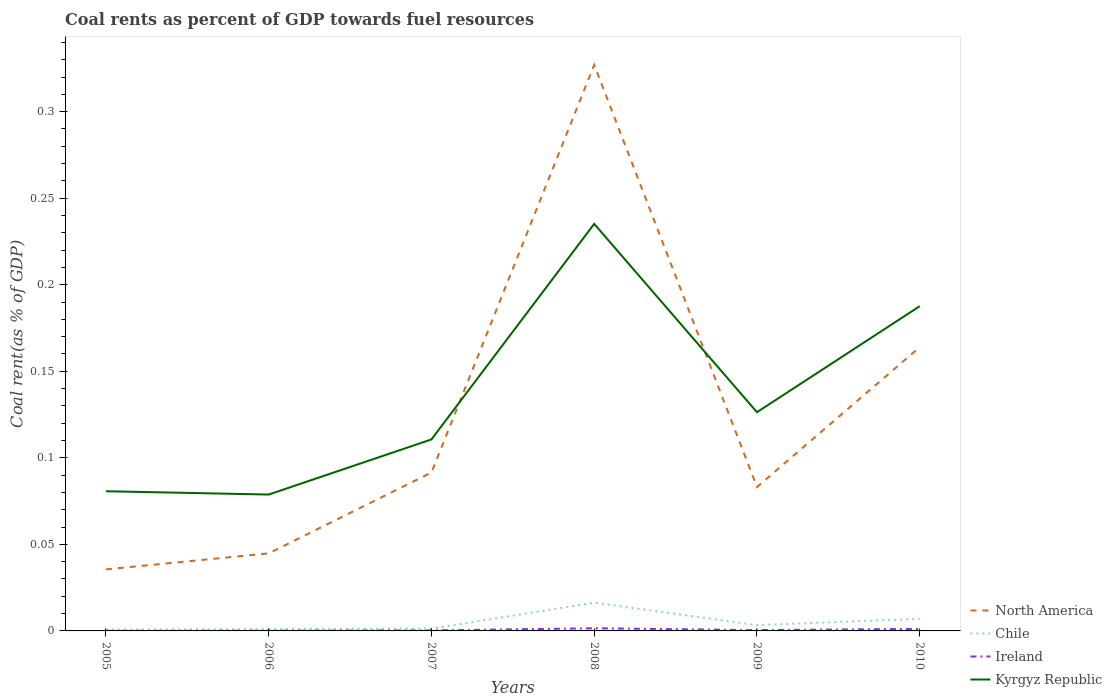How many different coloured lines are there?
Ensure brevity in your answer.  4. Does the line corresponding to Kyrgyz Republic intersect with the line corresponding to Chile?
Give a very brief answer. No. Is the number of lines equal to the number of legend labels?
Your response must be concise. Yes. Across all years, what is the maximum coal rent in Chile?
Offer a very short reply. 0. What is the total coal rent in North America in the graph?
Ensure brevity in your answer.  -0.28. What is the difference between the highest and the second highest coal rent in Ireland?
Offer a very short reply. 0. How many lines are there?
Your answer should be very brief. 4. How many years are there in the graph?
Give a very brief answer. 6. What is the difference between two consecutive major ticks on the Y-axis?
Provide a short and direct response. 0.05. Are the values on the major ticks of Y-axis written in scientific E-notation?
Your answer should be very brief. No. Does the graph contain grids?
Give a very brief answer. No. Where does the legend appear in the graph?
Your answer should be compact. Bottom right. What is the title of the graph?
Your answer should be compact. Coal rents as percent of GDP towards fuel resources. Does "Poland" appear as one of the legend labels in the graph?
Your response must be concise. No. What is the label or title of the X-axis?
Your answer should be very brief. Years. What is the label or title of the Y-axis?
Provide a short and direct response. Coal rent(as % of GDP). What is the Coal rent(as % of GDP) of North America in 2005?
Offer a very short reply. 0.04. What is the Coal rent(as % of GDP) of Chile in 2005?
Keep it short and to the point. 0. What is the Coal rent(as % of GDP) of Ireland in 2005?
Keep it short and to the point. 7.66717495498807e-5. What is the Coal rent(as % of GDP) of Kyrgyz Republic in 2005?
Provide a short and direct response. 0.08. What is the Coal rent(as % of GDP) in North America in 2006?
Keep it short and to the point. 0.04. What is the Coal rent(as % of GDP) of Chile in 2006?
Make the answer very short. 0. What is the Coal rent(as % of GDP) of Ireland in 2006?
Keep it short and to the point. 0. What is the Coal rent(as % of GDP) of Kyrgyz Republic in 2006?
Offer a very short reply. 0.08. What is the Coal rent(as % of GDP) of North America in 2007?
Offer a terse response. 0.09. What is the Coal rent(as % of GDP) of Chile in 2007?
Your answer should be compact. 0. What is the Coal rent(as % of GDP) in Ireland in 2007?
Ensure brevity in your answer.  0. What is the Coal rent(as % of GDP) in Kyrgyz Republic in 2007?
Your answer should be compact. 0.11. What is the Coal rent(as % of GDP) in North America in 2008?
Offer a terse response. 0.33. What is the Coal rent(as % of GDP) in Chile in 2008?
Provide a succinct answer. 0.02. What is the Coal rent(as % of GDP) of Ireland in 2008?
Make the answer very short. 0. What is the Coal rent(as % of GDP) in Kyrgyz Republic in 2008?
Give a very brief answer. 0.24. What is the Coal rent(as % of GDP) in North America in 2009?
Give a very brief answer. 0.08. What is the Coal rent(as % of GDP) of Chile in 2009?
Provide a short and direct response. 0. What is the Coal rent(as % of GDP) in Ireland in 2009?
Give a very brief answer. 0. What is the Coal rent(as % of GDP) of Kyrgyz Republic in 2009?
Provide a short and direct response. 0.13. What is the Coal rent(as % of GDP) of North America in 2010?
Ensure brevity in your answer.  0.16. What is the Coal rent(as % of GDP) of Chile in 2010?
Offer a terse response. 0.01. What is the Coal rent(as % of GDP) of Ireland in 2010?
Your answer should be very brief. 0. What is the Coal rent(as % of GDP) in Kyrgyz Republic in 2010?
Keep it short and to the point. 0.19. Across all years, what is the maximum Coal rent(as % of GDP) in North America?
Offer a terse response. 0.33. Across all years, what is the maximum Coal rent(as % of GDP) of Chile?
Keep it short and to the point. 0.02. Across all years, what is the maximum Coal rent(as % of GDP) of Ireland?
Give a very brief answer. 0. Across all years, what is the maximum Coal rent(as % of GDP) of Kyrgyz Republic?
Provide a succinct answer. 0.24. Across all years, what is the minimum Coal rent(as % of GDP) of North America?
Keep it short and to the point. 0.04. Across all years, what is the minimum Coal rent(as % of GDP) in Chile?
Provide a short and direct response. 0. Across all years, what is the minimum Coal rent(as % of GDP) of Ireland?
Give a very brief answer. 7.66717495498807e-5. Across all years, what is the minimum Coal rent(as % of GDP) in Kyrgyz Republic?
Ensure brevity in your answer.  0.08. What is the total Coal rent(as % of GDP) in North America in the graph?
Your answer should be very brief. 0.75. What is the total Coal rent(as % of GDP) in Chile in the graph?
Offer a terse response. 0.03. What is the total Coal rent(as % of GDP) in Ireland in the graph?
Your answer should be very brief. 0. What is the total Coal rent(as % of GDP) in Kyrgyz Republic in the graph?
Provide a succinct answer. 0.82. What is the difference between the Coal rent(as % of GDP) in North America in 2005 and that in 2006?
Provide a succinct answer. -0.01. What is the difference between the Coal rent(as % of GDP) in Chile in 2005 and that in 2006?
Your response must be concise. -0. What is the difference between the Coal rent(as % of GDP) in Ireland in 2005 and that in 2006?
Provide a succinct answer. -0. What is the difference between the Coal rent(as % of GDP) of Kyrgyz Republic in 2005 and that in 2006?
Your response must be concise. 0. What is the difference between the Coal rent(as % of GDP) of North America in 2005 and that in 2007?
Ensure brevity in your answer.  -0.06. What is the difference between the Coal rent(as % of GDP) in Chile in 2005 and that in 2007?
Keep it short and to the point. -0. What is the difference between the Coal rent(as % of GDP) in Ireland in 2005 and that in 2007?
Offer a terse response. -0. What is the difference between the Coal rent(as % of GDP) of Kyrgyz Republic in 2005 and that in 2007?
Give a very brief answer. -0.03. What is the difference between the Coal rent(as % of GDP) of North America in 2005 and that in 2008?
Your answer should be compact. -0.29. What is the difference between the Coal rent(as % of GDP) of Chile in 2005 and that in 2008?
Offer a terse response. -0.02. What is the difference between the Coal rent(as % of GDP) of Ireland in 2005 and that in 2008?
Provide a short and direct response. -0. What is the difference between the Coal rent(as % of GDP) of Kyrgyz Republic in 2005 and that in 2008?
Offer a terse response. -0.15. What is the difference between the Coal rent(as % of GDP) in North America in 2005 and that in 2009?
Keep it short and to the point. -0.05. What is the difference between the Coal rent(as % of GDP) of Chile in 2005 and that in 2009?
Ensure brevity in your answer.  -0. What is the difference between the Coal rent(as % of GDP) in Ireland in 2005 and that in 2009?
Keep it short and to the point. -0. What is the difference between the Coal rent(as % of GDP) in Kyrgyz Republic in 2005 and that in 2009?
Provide a short and direct response. -0.05. What is the difference between the Coal rent(as % of GDP) in North America in 2005 and that in 2010?
Your answer should be very brief. -0.13. What is the difference between the Coal rent(as % of GDP) in Chile in 2005 and that in 2010?
Your answer should be compact. -0.01. What is the difference between the Coal rent(as % of GDP) in Ireland in 2005 and that in 2010?
Keep it short and to the point. -0. What is the difference between the Coal rent(as % of GDP) in Kyrgyz Republic in 2005 and that in 2010?
Offer a terse response. -0.11. What is the difference between the Coal rent(as % of GDP) of North America in 2006 and that in 2007?
Provide a succinct answer. -0.05. What is the difference between the Coal rent(as % of GDP) in Chile in 2006 and that in 2007?
Ensure brevity in your answer.  -0. What is the difference between the Coal rent(as % of GDP) of Ireland in 2006 and that in 2007?
Ensure brevity in your answer.  -0. What is the difference between the Coal rent(as % of GDP) of Kyrgyz Republic in 2006 and that in 2007?
Give a very brief answer. -0.03. What is the difference between the Coal rent(as % of GDP) in North America in 2006 and that in 2008?
Offer a terse response. -0.28. What is the difference between the Coal rent(as % of GDP) in Chile in 2006 and that in 2008?
Keep it short and to the point. -0.02. What is the difference between the Coal rent(as % of GDP) in Ireland in 2006 and that in 2008?
Ensure brevity in your answer.  -0. What is the difference between the Coal rent(as % of GDP) of Kyrgyz Republic in 2006 and that in 2008?
Your answer should be very brief. -0.16. What is the difference between the Coal rent(as % of GDP) in North America in 2006 and that in 2009?
Offer a terse response. -0.04. What is the difference between the Coal rent(as % of GDP) in Chile in 2006 and that in 2009?
Your response must be concise. -0. What is the difference between the Coal rent(as % of GDP) in Ireland in 2006 and that in 2009?
Your response must be concise. -0. What is the difference between the Coal rent(as % of GDP) in Kyrgyz Republic in 2006 and that in 2009?
Your answer should be very brief. -0.05. What is the difference between the Coal rent(as % of GDP) of North America in 2006 and that in 2010?
Provide a succinct answer. -0.12. What is the difference between the Coal rent(as % of GDP) of Chile in 2006 and that in 2010?
Offer a very short reply. -0.01. What is the difference between the Coal rent(as % of GDP) of Ireland in 2006 and that in 2010?
Give a very brief answer. -0. What is the difference between the Coal rent(as % of GDP) in Kyrgyz Republic in 2006 and that in 2010?
Keep it short and to the point. -0.11. What is the difference between the Coal rent(as % of GDP) in North America in 2007 and that in 2008?
Offer a very short reply. -0.24. What is the difference between the Coal rent(as % of GDP) in Chile in 2007 and that in 2008?
Ensure brevity in your answer.  -0.01. What is the difference between the Coal rent(as % of GDP) of Ireland in 2007 and that in 2008?
Give a very brief answer. -0. What is the difference between the Coal rent(as % of GDP) of Kyrgyz Republic in 2007 and that in 2008?
Offer a very short reply. -0.12. What is the difference between the Coal rent(as % of GDP) of North America in 2007 and that in 2009?
Offer a terse response. 0.01. What is the difference between the Coal rent(as % of GDP) in Chile in 2007 and that in 2009?
Make the answer very short. -0. What is the difference between the Coal rent(as % of GDP) in Ireland in 2007 and that in 2009?
Provide a short and direct response. -0. What is the difference between the Coal rent(as % of GDP) of Kyrgyz Republic in 2007 and that in 2009?
Your answer should be very brief. -0.02. What is the difference between the Coal rent(as % of GDP) in North America in 2007 and that in 2010?
Give a very brief answer. -0.07. What is the difference between the Coal rent(as % of GDP) in Chile in 2007 and that in 2010?
Your answer should be compact. -0.01. What is the difference between the Coal rent(as % of GDP) in Ireland in 2007 and that in 2010?
Provide a succinct answer. -0. What is the difference between the Coal rent(as % of GDP) of Kyrgyz Republic in 2007 and that in 2010?
Offer a very short reply. -0.08. What is the difference between the Coal rent(as % of GDP) in North America in 2008 and that in 2009?
Provide a succinct answer. 0.24. What is the difference between the Coal rent(as % of GDP) of Chile in 2008 and that in 2009?
Offer a very short reply. 0.01. What is the difference between the Coal rent(as % of GDP) in Kyrgyz Republic in 2008 and that in 2009?
Provide a succinct answer. 0.11. What is the difference between the Coal rent(as % of GDP) in North America in 2008 and that in 2010?
Provide a short and direct response. 0.16. What is the difference between the Coal rent(as % of GDP) in Chile in 2008 and that in 2010?
Offer a very short reply. 0.01. What is the difference between the Coal rent(as % of GDP) in Ireland in 2008 and that in 2010?
Ensure brevity in your answer.  0. What is the difference between the Coal rent(as % of GDP) of Kyrgyz Republic in 2008 and that in 2010?
Ensure brevity in your answer.  0.05. What is the difference between the Coal rent(as % of GDP) in North America in 2009 and that in 2010?
Provide a succinct answer. -0.08. What is the difference between the Coal rent(as % of GDP) of Chile in 2009 and that in 2010?
Offer a terse response. -0. What is the difference between the Coal rent(as % of GDP) of Ireland in 2009 and that in 2010?
Offer a terse response. -0. What is the difference between the Coal rent(as % of GDP) of Kyrgyz Republic in 2009 and that in 2010?
Offer a very short reply. -0.06. What is the difference between the Coal rent(as % of GDP) of North America in 2005 and the Coal rent(as % of GDP) of Chile in 2006?
Give a very brief answer. 0.03. What is the difference between the Coal rent(as % of GDP) of North America in 2005 and the Coal rent(as % of GDP) of Ireland in 2006?
Make the answer very short. 0.04. What is the difference between the Coal rent(as % of GDP) in North America in 2005 and the Coal rent(as % of GDP) in Kyrgyz Republic in 2006?
Keep it short and to the point. -0.04. What is the difference between the Coal rent(as % of GDP) in Chile in 2005 and the Coal rent(as % of GDP) in Ireland in 2006?
Provide a short and direct response. 0. What is the difference between the Coal rent(as % of GDP) of Chile in 2005 and the Coal rent(as % of GDP) of Kyrgyz Republic in 2006?
Give a very brief answer. -0.08. What is the difference between the Coal rent(as % of GDP) of Ireland in 2005 and the Coal rent(as % of GDP) of Kyrgyz Republic in 2006?
Your answer should be very brief. -0.08. What is the difference between the Coal rent(as % of GDP) in North America in 2005 and the Coal rent(as % of GDP) in Chile in 2007?
Your response must be concise. 0.03. What is the difference between the Coal rent(as % of GDP) in North America in 2005 and the Coal rent(as % of GDP) in Ireland in 2007?
Make the answer very short. 0.04. What is the difference between the Coal rent(as % of GDP) of North America in 2005 and the Coal rent(as % of GDP) of Kyrgyz Republic in 2007?
Your response must be concise. -0.08. What is the difference between the Coal rent(as % of GDP) of Chile in 2005 and the Coal rent(as % of GDP) of Ireland in 2007?
Ensure brevity in your answer.  0. What is the difference between the Coal rent(as % of GDP) of Chile in 2005 and the Coal rent(as % of GDP) of Kyrgyz Republic in 2007?
Ensure brevity in your answer.  -0.11. What is the difference between the Coal rent(as % of GDP) of Ireland in 2005 and the Coal rent(as % of GDP) of Kyrgyz Republic in 2007?
Your answer should be very brief. -0.11. What is the difference between the Coal rent(as % of GDP) of North America in 2005 and the Coal rent(as % of GDP) of Chile in 2008?
Offer a terse response. 0.02. What is the difference between the Coal rent(as % of GDP) in North America in 2005 and the Coal rent(as % of GDP) in Ireland in 2008?
Keep it short and to the point. 0.03. What is the difference between the Coal rent(as % of GDP) in North America in 2005 and the Coal rent(as % of GDP) in Kyrgyz Republic in 2008?
Your response must be concise. -0.2. What is the difference between the Coal rent(as % of GDP) of Chile in 2005 and the Coal rent(as % of GDP) of Ireland in 2008?
Your answer should be compact. -0. What is the difference between the Coal rent(as % of GDP) of Chile in 2005 and the Coal rent(as % of GDP) of Kyrgyz Republic in 2008?
Offer a very short reply. -0.23. What is the difference between the Coal rent(as % of GDP) of Ireland in 2005 and the Coal rent(as % of GDP) of Kyrgyz Republic in 2008?
Your response must be concise. -0.24. What is the difference between the Coal rent(as % of GDP) in North America in 2005 and the Coal rent(as % of GDP) in Chile in 2009?
Your answer should be very brief. 0.03. What is the difference between the Coal rent(as % of GDP) of North America in 2005 and the Coal rent(as % of GDP) of Ireland in 2009?
Offer a very short reply. 0.04. What is the difference between the Coal rent(as % of GDP) in North America in 2005 and the Coal rent(as % of GDP) in Kyrgyz Republic in 2009?
Give a very brief answer. -0.09. What is the difference between the Coal rent(as % of GDP) of Chile in 2005 and the Coal rent(as % of GDP) of Kyrgyz Republic in 2009?
Offer a terse response. -0.13. What is the difference between the Coal rent(as % of GDP) of Ireland in 2005 and the Coal rent(as % of GDP) of Kyrgyz Republic in 2009?
Offer a terse response. -0.13. What is the difference between the Coal rent(as % of GDP) of North America in 2005 and the Coal rent(as % of GDP) of Chile in 2010?
Your answer should be very brief. 0.03. What is the difference between the Coal rent(as % of GDP) in North America in 2005 and the Coal rent(as % of GDP) in Ireland in 2010?
Ensure brevity in your answer.  0.03. What is the difference between the Coal rent(as % of GDP) in North America in 2005 and the Coal rent(as % of GDP) in Kyrgyz Republic in 2010?
Your response must be concise. -0.15. What is the difference between the Coal rent(as % of GDP) in Chile in 2005 and the Coal rent(as % of GDP) in Ireland in 2010?
Offer a very short reply. -0. What is the difference between the Coal rent(as % of GDP) of Chile in 2005 and the Coal rent(as % of GDP) of Kyrgyz Republic in 2010?
Make the answer very short. -0.19. What is the difference between the Coal rent(as % of GDP) of Ireland in 2005 and the Coal rent(as % of GDP) of Kyrgyz Republic in 2010?
Offer a terse response. -0.19. What is the difference between the Coal rent(as % of GDP) in North America in 2006 and the Coal rent(as % of GDP) in Chile in 2007?
Provide a short and direct response. 0.04. What is the difference between the Coal rent(as % of GDP) of North America in 2006 and the Coal rent(as % of GDP) of Ireland in 2007?
Your response must be concise. 0.04. What is the difference between the Coal rent(as % of GDP) of North America in 2006 and the Coal rent(as % of GDP) of Kyrgyz Republic in 2007?
Provide a short and direct response. -0.07. What is the difference between the Coal rent(as % of GDP) of Chile in 2006 and the Coal rent(as % of GDP) of Ireland in 2007?
Provide a short and direct response. 0. What is the difference between the Coal rent(as % of GDP) in Chile in 2006 and the Coal rent(as % of GDP) in Kyrgyz Republic in 2007?
Your answer should be very brief. -0.11. What is the difference between the Coal rent(as % of GDP) of Ireland in 2006 and the Coal rent(as % of GDP) of Kyrgyz Republic in 2007?
Your response must be concise. -0.11. What is the difference between the Coal rent(as % of GDP) of North America in 2006 and the Coal rent(as % of GDP) of Chile in 2008?
Provide a succinct answer. 0.03. What is the difference between the Coal rent(as % of GDP) in North America in 2006 and the Coal rent(as % of GDP) in Ireland in 2008?
Ensure brevity in your answer.  0.04. What is the difference between the Coal rent(as % of GDP) of North America in 2006 and the Coal rent(as % of GDP) of Kyrgyz Republic in 2008?
Ensure brevity in your answer.  -0.19. What is the difference between the Coal rent(as % of GDP) of Chile in 2006 and the Coal rent(as % of GDP) of Ireland in 2008?
Make the answer very short. -0. What is the difference between the Coal rent(as % of GDP) of Chile in 2006 and the Coal rent(as % of GDP) of Kyrgyz Republic in 2008?
Offer a very short reply. -0.23. What is the difference between the Coal rent(as % of GDP) of Ireland in 2006 and the Coal rent(as % of GDP) of Kyrgyz Republic in 2008?
Give a very brief answer. -0.24. What is the difference between the Coal rent(as % of GDP) of North America in 2006 and the Coal rent(as % of GDP) of Chile in 2009?
Your answer should be compact. 0.04. What is the difference between the Coal rent(as % of GDP) in North America in 2006 and the Coal rent(as % of GDP) in Ireland in 2009?
Offer a terse response. 0.04. What is the difference between the Coal rent(as % of GDP) of North America in 2006 and the Coal rent(as % of GDP) of Kyrgyz Republic in 2009?
Make the answer very short. -0.08. What is the difference between the Coal rent(as % of GDP) of Chile in 2006 and the Coal rent(as % of GDP) of Ireland in 2009?
Keep it short and to the point. 0. What is the difference between the Coal rent(as % of GDP) in Chile in 2006 and the Coal rent(as % of GDP) in Kyrgyz Republic in 2009?
Your answer should be compact. -0.13. What is the difference between the Coal rent(as % of GDP) in Ireland in 2006 and the Coal rent(as % of GDP) in Kyrgyz Republic in 2009?
Offer a very short reply. -0.13. What is the difference between the Coal rent(as % of GDP) in North America in 2006 and the Coal rent(as % of GDP) in Chile in 2010?
Keep it short and to the point. 0.04. What is the difference between the Coal rent(as % of GDP) of North America in 2006 and the Coal rent(as % of GDP) of Ireland in 2010?
Offer a terse response. 0.04. What is the difference between the Coal rent(as % of GDP) of North America in 2006 and the Coal rent(as % of GDP) of Kyrgyz Republic in 2010?
Provide a short and direct response. -0.14. What is the difference between the Coal rent(as % of GDP) of Chile in 2006 and the Coal rent(as % of GDP) of Ireland in 2010?
Offer a terse response. -0. What is the difference between the Coal rent(as % of GDP) of Chile in 2006 and the Coal rent(as % of GDP) of Kyrgyz Republic in 2010?
Ensure brevity in your answer.  -0.19. What is the difference between the Coal rent(as % of GDP) of Ireland in 2006 and the Coal rent(as % of GDP) of Kyrgyz Republic in 2010?
Your answer should be very brief. -0.19. What is the difference between the Coal rent(as % of GDP) of North America in 2007 and the Coal rent(as % of GDP) of Chile in 2008?
Offer a very short reply. 0.08. What is the difference between the Coal rent(as % of GDP) in North America in 2007 and the Coal rent(as % of GDP) in Ireland in 2008?
Your response must be concise. 0.09. What is the difference between the Coal rent(as % of GDP) of North America in 2007 and the Coal rent(as % of GDP) of Kyrgyz Republic in 2008?
Your answer should be compact. -0.14. What is the difference between the Coal rent(as % of GDP) of Chile in 2007 and the Coal rent(as % of GDP) of Ireland in 2008?
Offer a terse response. -0. What is the difference between the Coal rent(as % of GDP) in Chile in 2007 and the Coal rent(as % of GDP) in Kyrgyz Republic in 2008?
Provide a succinct answer. -0.23. What is the difference between the Coal rent(as % of GDP) in Ireland in 2007 and the Coal rent(as % of GDP) in Kyrgyz Republic in 2008?
Your answer should be very brief. -0.23. What is the difference between the Coal rent(as % of GDP) of North America in 2007 and the Coal rent(as % of GDP) of Chile in 2009?
Your answer should be very brief. 0.09. What is the difference between the Coal rent(as % of GDP) in North America in 2007 and the Coal rent(as % of GDP) in Ireland in 2009?
Provide a short and direct response. 0.09. What is the difference between the Coal rent(as % of GDP) of North America in 2007 and the Coal rent(as % of GDP) of Kyrgyz Republic in 2009?
Your answer should be very brief. -0.03. What is the difference between the Coal rent(as % of GDP) of Chile in 2007 and the Coal rent(as % of GDP) of Ireland in 2009?
Your answer should be compact. 0. What is the difference between the Coal rent(as % of GDP) of Chile in 2007 and the Coal rent(as % of GDP) of Kyrgyz Republic in 2009?
Offer a very short reply. -0.12. What is the difference between the Coal rent(as % of GDP) in Ireland in 2007 and the Coal rent(as % of GDP) in Kyrgyz Republic in 2009?
Keep it short and to the point. -0.13. What is the difference between the Coal rent(as % of GDP) in North America in 2007 and the Coal rent(as % of GDP) in Chile in 2010?
Provide a short and direct response. 0.08. What is the difference between the Coal rent(as % of GDP) of North America in 2007 and the Coal rent(as % of GDP) of Ireland in 2010?
Make the answer very short. 0.09. What is the difference between the Coal rent(as % of GDP) in North America in 2007 and the Coal rent(as % of GDP) in Kyrgyz Republic in 2010?
Give a very brief answer. -0.1. What is the difference between the Coal rent(as % of GDP) of Chile in 2007 and the Coal rent(as % of GDP) of Ireland in 2010?
Provide a short and direct response. 0. What is the difference between the Coal rent(as % of GDP) in Chile in 2007 and the Coal rent(as % of GDP) in Kyrgyz Republic in 2010?
Your response must be concise. -0.19. What is the difference between the Coal rent(as % of GDP) in Ireland in 2007 and the Coal rent(as % of GDP) in Kyrgyz Republic in 2010?
Give a very brief answer. -0.19. What is the difference between the Coal rent(as % of GDP) in North America in 2008 and the Coal rent(as % of GDP) in Chile in 2009?
Your answer should be very brief. 0.32. What is the difference between the Coal rent(as % of GDP) in North America in 2008 and the Coal rent(as % of GDP) in Ireland in 2009?
Offer a very short reply. 0.33. What is the difference between the Coal rent(as % of GDP) in North America in 2008 and the Coal rent(as % of GDP) in Kyrgyz Republic in 2009?
Provide a short and direct response. 0.2. What is the difference between the Coal rent(as % of GDP) of Chile in 2008 and the Coal rent(as % of GDP) of Ireland in 2009?
Provide a succinct answer. 0.02. What is the difference between the Coal rent(as % of GDP) in Chile in 2008 and the Coal rent(as % of GDP) in Kyrgyz Republic in 2009?
Offer a terse response. -0.11. What is the difference between the Coal rent(as % of GDP) of Ireland in 2008 and the Coal rent(as % of GDP) of Kyrgyz Republic in 2009?
Provide a short and direct response. -0.12. What is the difference between the Coal rent(as % of GDP) in North America in 2008 and the Coal rent(as % of GDP) in Chile in 2010?
Give a very brief answer. 0.32. What is the difference between the Coal rent(as % of GDP) in North America in 2008 and the Coal rent(as % of GDP) in Ireland in 2010?
Your response must be concise. 0.33. What is the difference between the Coal rent(as % of GDP) in North America in 2008 and the Coal rent(as % of GDP) in Kyrgyz Republic in 2010?
Offer a very short reply. 0.14. What is the difference between the Coal rent(as % of GDP) of Chile in 2008 and the Coal rent(as % of GDP) of Ireland in 2010?
Your response must be concise. 0.02. What is the difference between the Coal rent(as % of GDP) in Chile in 2008 and the Coal rent(as % of GDP) in Kyrgyz Republic in 2010?
Offer a terse response. -0.17. What is the difference between the Coal rent(as % of GDP) of Ireland in 2008 and the Coal rent(as % of GDP) of Kyrgyz Republic in 2010?
Keep it short and to the point. -0.19. What is the difference between the Coal rent(as % of GDP) in North America in 2009 and the Coal rent(as % of GDP) in Chile in 2010?
Give a very brief answer. 0.08. What is the difference between the Coal rent(as % of GDP) of North America in 2009 and the Coal rent(as % of GDP) of Ireland in 2010?
Offer a very short reply. 0.08. What is the difference between the Coal rent(as % of GDP) in North America in 2009 and the Coal rent(as % of GDP) in Kyrgyz Republic in 2010?
Give a very brief answer. -0.1. What is the difference between the Coal rent(as % of GDP) in Chile in 2009 and the Coal rent(as % of GDP) in Ireland in 2010?
Keep it short and to the point. 0. What is the difference between the Coal rent(as % of GDP) in Chile in 2009 and the Coal rent(as % of GDP) in Kyrgyz Republic in 2010?
Keep it short and to the point. -0.18. What is the difference between the Coal rent(as % of GDP) in Ireland in 2009 and the Coal rent(as % of GDP) in Kyrgyz Republic in 2010?
Ensure brevity in your answer.  -0.19. What is the average Coal rent(as % of GDP) of North America per year?
Provide a succinct answer. 0.12. What is the average Coal rent(as % of GDP) in Chile per year?
Your answer should be compact. 0.01. What is the average Coal rent(as % of GDP) in Ireland per year?
Offer a terse response. 0. What is the average Coal rent(as % of GDP) in Kyrgyz Republic per year?
Your response must be concise. 0.14. In the year 2005, what is the difference between the Coal rent(as % of GDP) in North America and Coal rent(as % of GDP) in Chile?
Your answer should be compact. 0.03. In the year 2005, what is the difference between the Coal rent(as % of GDP) of North America and Coal rent(as % of GDP) of Ireland?
Provide a short and direct response. 0.04. In the year 2005, what is the difference between the Coal rent(as % of GDP) of North America and Coal rent(as % of GDP) of Kyrgyz Republic?
Your answer should be very brief. -0.05. In the year 2005, what is the difference between the Coal rent(as % of GDP) of Chile and Coal rent(as % of GDP) of Ireland?
Ensure brevity in your answer.  0. In the year 2005, what is the difference between the Coal rent(as % of GDP) in Chile and Coal rent(as % of GDP) in Kyrgyz Republic?
Your answer should be compact. -0.08. In the year 2005, what is the difference between the Coal rent(as % of GDP) of Ireland and Coal rent(as % of GDP) of Kyrgyz Republic?
Your answer should be compact. -0.08. In the year 2006, what is the difference between the Coal rent(as % of GDP) in North America and Coal rent(as % of GDP) in Chile?
Make the answer very short. 0.04. In the year 2006, what is the difference between the Coal rent(as % of GDP) in North America and Coal rent(as % of GDP) in Ireland?
Give a very brief answer. 0.04. In the year 2006, what is the difference between the Coal rent(as % of GDP) in North America and Coal rent(as % of GDP) in Kyrgyz Republic?
Make the answer very short. -0.03. In the year 2006, what is the difference between the Coal rent(as % of GDP) of Chile and Coal rent(as % of GDP) of Ireland?
Your answer should be very brief. 0. In the year 2006, what is the difference between the Coal rent(as % of GDP) in Chile and Coal rent(as % of GDP) in Kyrgyz Republic?
Make the answer very short. -0.08. In the year 2006, what is the difference between the Coal rent(as % of GDP) of Ireland and Coal rent(as % of GDP) of Kyrgyz Republic?
Offer a terse response. -0.08. In the year 2007, what is the difference between the Coal rent(as % of GDP) of North America and Coal rent(as % of GDP) of Chile?
Keep it short and to the point. 0.09. In the year 2007, what is the difference between the Coal rent(as % of GDP) in North America and Coal rent(as % of GDP) in Ireland?
Ensure brevity in your answer.  0.09. In the year 2007, what is the difference between the Coal rent(as % of GDP) in North America and Coal rent(as % of GDP) in Kyrgyz Republic?
Make the answer very short. -0.02. In the year 2007, what is the difference between the Coal rent(as % of GDP) in Chile and Coal rent(as % of GDP) in Ireland?
Your response must be concise. 0. In the year 2007, what is the difference between the Coal rent(as % of GDP) of Chile and Coal rent(as % of GDP) of Kyrgyz Republic?
Make the answer very short. -0.11. In the year 2007, what is the difference between the Coal rent(as % of GDP) of Ireland and Coal rent(as % of GDP) of Kyrgyz Republic?
Offer a very short reply. -0.11. In the year 2008, what is the difference between the Coal rent(as % of GDP) in North America and Coal rent(as % of GDP) in Chile?
Your answer should be compact. 0.31. In the year 2008, what is the difference between the Coal rent(as % of GDP) of North America and Coal rent(as % of GDP) of Ireland?
Keep it short and to the point. 0.33. In the year 2008, what is the difference between the Coal rent(as % of GDP) in North America and Coal rent(as % of GDP) in Kyrgyz Republic?
Make the answer very short. 0.09. In the year 2008, what is the difference between the Coal rent(as % of GDP) in Chile and Coal rent(as % of GDP) in Ireland?
Give a very brief answer. 0.01. In the year 2008, what is the difference between the Coal rent(as % of GDP) in Chile and Coal rent(as % of GDP) in Kyrgyz Republic?
Your response must be concise. -0.22. In the year 2008, what is the difference between the Coal rent(as % of GDP) in Ireland and Coal rent(as % of GDP) in Kyrgyz Republic?
Provide a short and direct response. -0.23. In the year 2009, what is the difference between the Coal rent(as % of GDP) in North America and Coal rent(as % of GDP) in Chile?
Your answer should be compact. 0.08. In the year 2009, what is the difference between the Coal rent(as % of GDP) of North America and Coal rent(as % of GDP) of Ireland?
Ensure brevity in your answer.  0.08. In the year 2009, what is the difference between the Coal rent(as % of GDP) in North America and Coal rent(as % of GDP) in Kyrgyz Republic?
Keep it short and to the point. -0.04. In the year 2009, what is the difference between the Coal rent(as % of GDP) of Chile and Coal rent(as % of GDP) of Ireland?
Offer a terse response. 0. In the year 2009, what is the difference between the Coal rent(as % of GDP) of Chile and Coal rent(as % of GDP) of Kyrgyz Republic?
Offer a terse response. -0.12. In the year 2009, what is the difference between the Coal rent(as % of GDP) of Ireland and Coal rent(as % of GDP) of Kyrgyz Republic?
Provide a short and direct response. -0.13. In the year 2010, what is the difference between the Coal rent(as % of GDP) of North America and Coal rent(as % of GDP) of Chile?
Make the answer very short. 0.16. In the year 2010, what is the difference between the Coal rent(as % of GDP) of North America and Coal rent(as % of GDP) of Ireland?
Give a very brief answer. 0.16. In the year 2010, what is the difference between the Coal rent(as % of GDP) of North America and Coal rent(as % of GDP) of Kyrgyz Republic?
Offer a very short reply. -0.02. In the year 2010, what is the difference between the Coal rent(as % of GDP) in Chile and Coal rent(as % of GDP) in Ireland?
Offer a terse response. 0.01. In the year 2010, what is the difference between the Coal rent(as % of GDP) in Chile and Coal rent(as % of GDP) in Kyrgyz Republic?
Offer a very short reply. -0.18. In the year 2010, what is the difference between the Coal rent(as % of GDP) of Ireland and Coal rent(as % of GDP) of Kyrgyz Republic?
Make the answer very short. -0.19. What is the ratio of the Coal rent(as % of GDP) of North America in 2005 to that in 2006?
Ensure brevity in your answer.  0.79. What is the ratio of the Coal rent(as % of GDP) of Chile in 2005 to that in 2006?
Your response must be concise. 0.69. What is the ratio of the Coal rent(as % of GDP) in Ireland in 2005 to that in 2006?
Give a very brief answer. 0.67. What is the ratio of the Coal rent(as % of GDP) in Kyrgyz Republic in 2005 to that in 2006?
Offer a very short reply. 1.02. What is the ratio of the Coal rent(as % of GDP) of North America in 2005 to that in 2007?
Ensure brevity in your answer.  0.39. What is the ratio of the Coal rent(as % of GDP) of Chile in 2005 to that in 2007?
Provide a short and direct response. 0.53. What is the ratio of the Coal rent(as % of GDP) in Ireland in 2005 to that in 2007?
Offer a very short reply. 0.25. What is the ratio of the Coal rent(as % of GDP) of Kyrgyz Republic in 2005 to that in 2007?
Your answer should be compact. 0.73. What is the ratio of the Coal rent(as % of GDP) of North America in 2005 to that in 2008?
Your answer should be compact. 0.11. What is the ratio of the Coal rent(as % of GDP) of Chile in 2005 to that in 2008?
Keep it short and to the point. 0.04. What is the ratio of the Coal rent(as % of GDP) of Ireland in 2005 to that in 2008?
Your answer should be very brief. 0.05. What is the ratio of the Coal rent(as % of GDP) in Kyrgyz Republic in 2005 to that in 2008?
Your response must be concise. 0.34. What is the ratio of the Coal rent(as % of GDP) of North America in 2005 to that in 2009?
Give a very brief answer. 0.43. What is the ratio of the Coal rent(as % of GDP) in Chile in 2005 to that in 2009?
Give a very brief answer. 0.22. What is the ratio of the Coal rent(as % of GDP) in Ireland in 2005 to that in 2009?
Offer a very short reply. 0.16. What is the ratio of the Coal rent(as % of GDP) of Kyrgyz Republic in 2005 to that in 2009?
Provide a succinct answer. 0.64. What is the ratio of the Coal rent(as % of GDP) of North America in 2005 to that in 2010?
Make the answer very short. 0.22. What is the ratio of the Coal rent(as % of GDP) in Chile in 2005 to that in 2010?
Your answer should be very brief. 0.1. What is the ratio of the Coal rent(as % of GDP) of Ireland in 2005 to that in 2010?
Offer a terse response. 0.07. What is the ratio of the Coal rent(as % of GDP) in Kyrgyz Republic in 2005 to that in 2010?
Make the answer very short. 0.43. What is the ratio of the Coal rent(as % of GDP) of North America in 2006 to that in 2007?
Your response must be concise. 0.49. What is the ratio of the Coal rent(as % of GDP) of Chile in 2006 to that in 2007?
Offer a very short reply. 0.76. What is the ratio of the Coal rent(as % of GDP) in Ireland in 2006 to that in 2007?
Ensure brevity in your answer.  0.37. What is the ratio of the Coal rent(as % of GDP) in Kyrgyz Republic in 2006 to that in 2007?
Provide a succinct answer. 0.71. What is the ratio of the Coal rent(as % of GDP) of North America in 2006 to that in 2008?
Offer a very short reply. 0.14. What is the ratio of the Coal rent(as % of GDP) of Chile in 2006 to that in 2008?
Your answer should be compact. 0.06. What is the ratio of the Coal rent(as % of GDP) in Ireland in 2006 to that in 2008?
Your answer should be compact. 0.07. What is the ratio of the Coal rent(as % of GDP) in Kyrgyz Republic in 2006 to that in 2008?
Ensure brevity in your answer.  0.34. What is the ratio of the Coal rent(as % of GDP) in North America in 2006 to that in 2009?
Your response must be concise. 0.54. What is the ratio of the Coal rent(as % of GDP) of Chile in 2006 to that in 2009?
Your answer should be very brief. 0.31. What is the ratio of the Coal rent(as % of GDP) in Ireland in 2006 to that in 2009?
Offer a very short reply. 0.23. What is the ratio of the Coal rent(as % of GDP) in Kyrgyz Republic in 2006 to that in 2009?
Provide a short and direct response. 0.62. What is the ratio of the Coal rent(as % of GDP) of North America in 2006 to that in 2010?
Ensure brevity in your answer.  0.27. What is the ratio of the Coal rent(as % of GDP) in Chile in 2006 to that in 2010?
Give a very brief answer. 0.15. What is the ratio of the Coal rent(as % of GDP) of Ireland in 2006 to that in 2010?
Your answer should be compact. 0.1. What is the ratio of the Coal rent(as % of GDP) in Kyrgyz Republic in 2006 to that in 2010?
Your answer should be compact. 0.42. What is the ratio of the Coal rent(as % of GDP) of North America in 2007 to that in 2008?
Give a very brief answer. 0.28. What is the ratio of the Coal rent(as % of GDP) of Chile in 2007 to that in 2008?
Offer a terse response. 0.08. What is the ratio of the Coal rent(as % of GDP) in Ireland in 2007 to that in 2008?
Ensure brevity in your answer.  0.2. What is the ratio of the Coal rent(as % of GDP) in Kyrgyz Republic in 2007 to that in 2008?
Provide a succinct answer. 0.47. What is the ratio of the Coal rent(as % of GDP) in North America in 2007 to that in 2009?
Ensure brevity in your answer.  1.1. What is the ratio of the Coal rent(as % of GDP) in Chile in 2007 to that in 2009?
Ensure brevity in your answer.  0.42. What is the ratio of the Coal rent(as % of GDP) of Ireland in 2007 to that in 2009?
Offer a terse response. 0.63. What is the ratio of the Coal rent(as % of GDP) in Kyrgyz Republic in 2007 to that in 2009?
Your answer should be compact. 0.88. What is the ratio of the Coal rent(as % of GDP) of North America in 2007 to that in 2010?
Provide a short and direct response. 0.56. What is the ratio of the Coal rent(as % of GDP) of Chile in 2007 to that in 2010?
Keep it short and to the point. 0.2. What is the ratio of the Coal rent(as % of GDP) in Ireland in 2007 to that in 2010?
Your response must be concise. 0.26. What is the ratio of the Coal rent(as % of GDP) of Kyrgyz Republic in 2007 to that in 2010?
Give a very brief answer. 0.59. What is the ratio of the Coal rent(as % of GDP) of North America in 2008 to that in 2009?
Ensure brevity in your answer.  3.93. What is the ratio of the Coal rent(as % of GDP) in Chile in 2008 to that in 2009?
Ensure brevity in your answer.  4.91. What is the ratio of the Coal rent(as % of GDP) of Ireland in 2008 to that in 2009?
Keep it short and to the point. 3.12. What is the ratio of the Coal rent(as % of GDP) in Kyrgyz Republic in 2008 to that in 2009?
Offer a very short reply. 1.86. What is the ratio of the Coal rent(as % of GDP) in North America in 2008 to that in 2010?
Offer a terse response. 1.99. What is the ratio of the Coal rent(as % of GDP) in Chile in 2008 to that in 2010?
Provide a succinct answer. 2.33. What is the ratio of the Coal rent(as % of GDP) in Ireland in 2008 to that in 2010?
Ensure brevity in your answer.  1.31. What is the ratio of the Coal rent(as % of GDP) in Kyrgyz Republic in 2008 to that in 2010?
Provide a short and direct response. 1.25. What is the ratio of the Coal rent(as % of GDP) in North America in 2009 to that in 2010?
Your response must be concise. 0.51. What is the ratio of the Coal rent(as % of GDP) in Chile in 2009 to that in 2010?
Your answer should be compact. 0.47. What is the ratio of the Coal rent(as % of GDP) of Ireland in 2009 to that in 2010?
Your response must be concise. 0.42. What is the ratio of the Coal rent(as % of GDP) in Kyrgyz Republic in 2009 to that in 2010?
Make the answer very short. 0.67. What is the difference between the highest and the second highest Coal rent(as % of GDP) in North America?
Provide a short and direct response. 0.16. What is the difference between the highest and the second highest Coal rent(as % of GDP) of Chile?
Provide a short and direct response. 0.01. What is the difference between the highest and the second highest Coal rent(as % of GDP) of Kyrgyz Republic?
Give a very brief answer. 0.05. What is the difference between the highest and the lowest Coal rent(as % of GDP) in North America?
Provide a short and direct response. 0.29. What is the difference between the highest and the lowest Coal rent(as % of GDP) in Chile?
Make the answer very short. 0.02. What is the difference between the highest and the lowest Coal rent(as % of GDP) in Ireland?
Provide a succinct answer. 0. What is the difference between the highest and the lowest Coal rent(as % of GDP) of Kyrgyz Republic?
Provide a succinct answer. 0.16. 